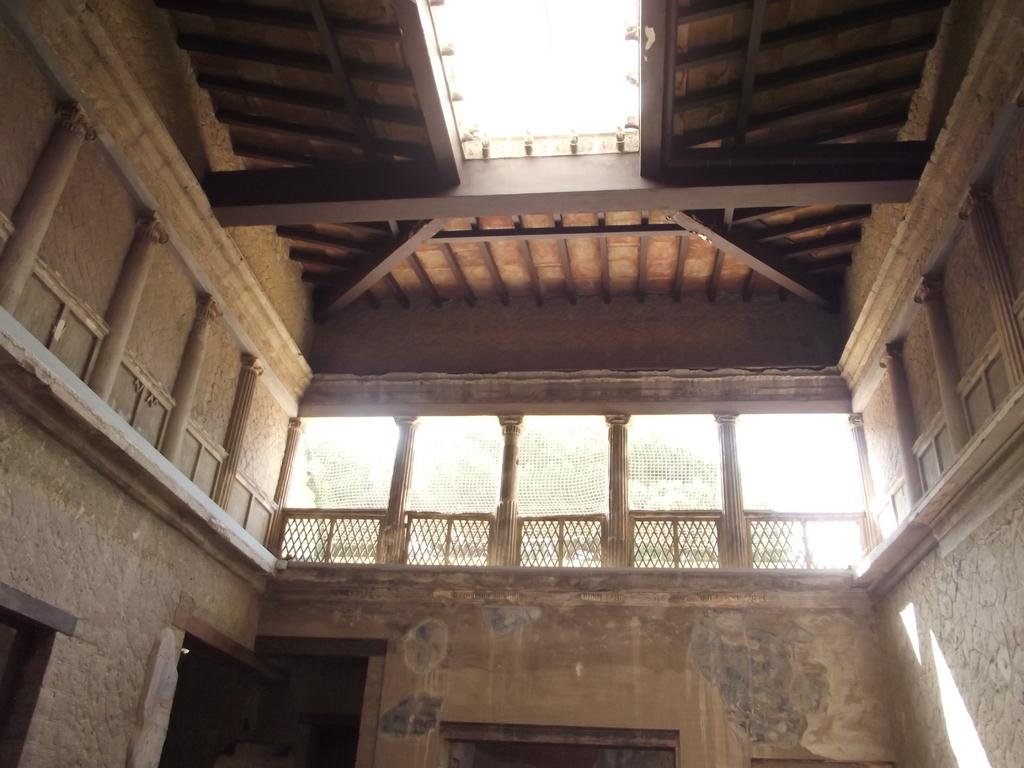Where was the image taken? The image is taken inside a house. What can be seen in the center of the image? There is a railing in the center of the image. What are the doors in the image used for? The doors on the walls are used for entering and exiting rooms. What is visible at the top of the image? The ceiling is visible at the top of the image. What can be seen outside the house? Trees are visible outside the house. What type of mist can be seen surrounding the box in the image? There is no mist or box present in the image. 